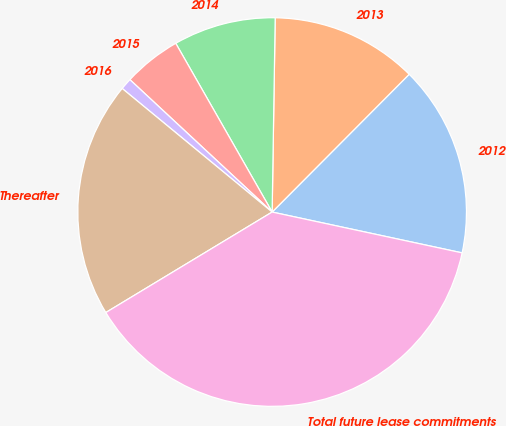<chart> <loc_0><loc_0><loc_500><loc_500><pie_chart><fcel>2012<fcel>2013<fcel>2014<fcel>2015<fcel>2016<fcel>Thereafter<fcel>Total future lease commitments<nl><fcel>15.91%<fcel>12.21%<fcel>8.51%<fcel>4.81%<fcel>0.96%<fcel>19.62%<fcel>37.98%<nl></chart> 